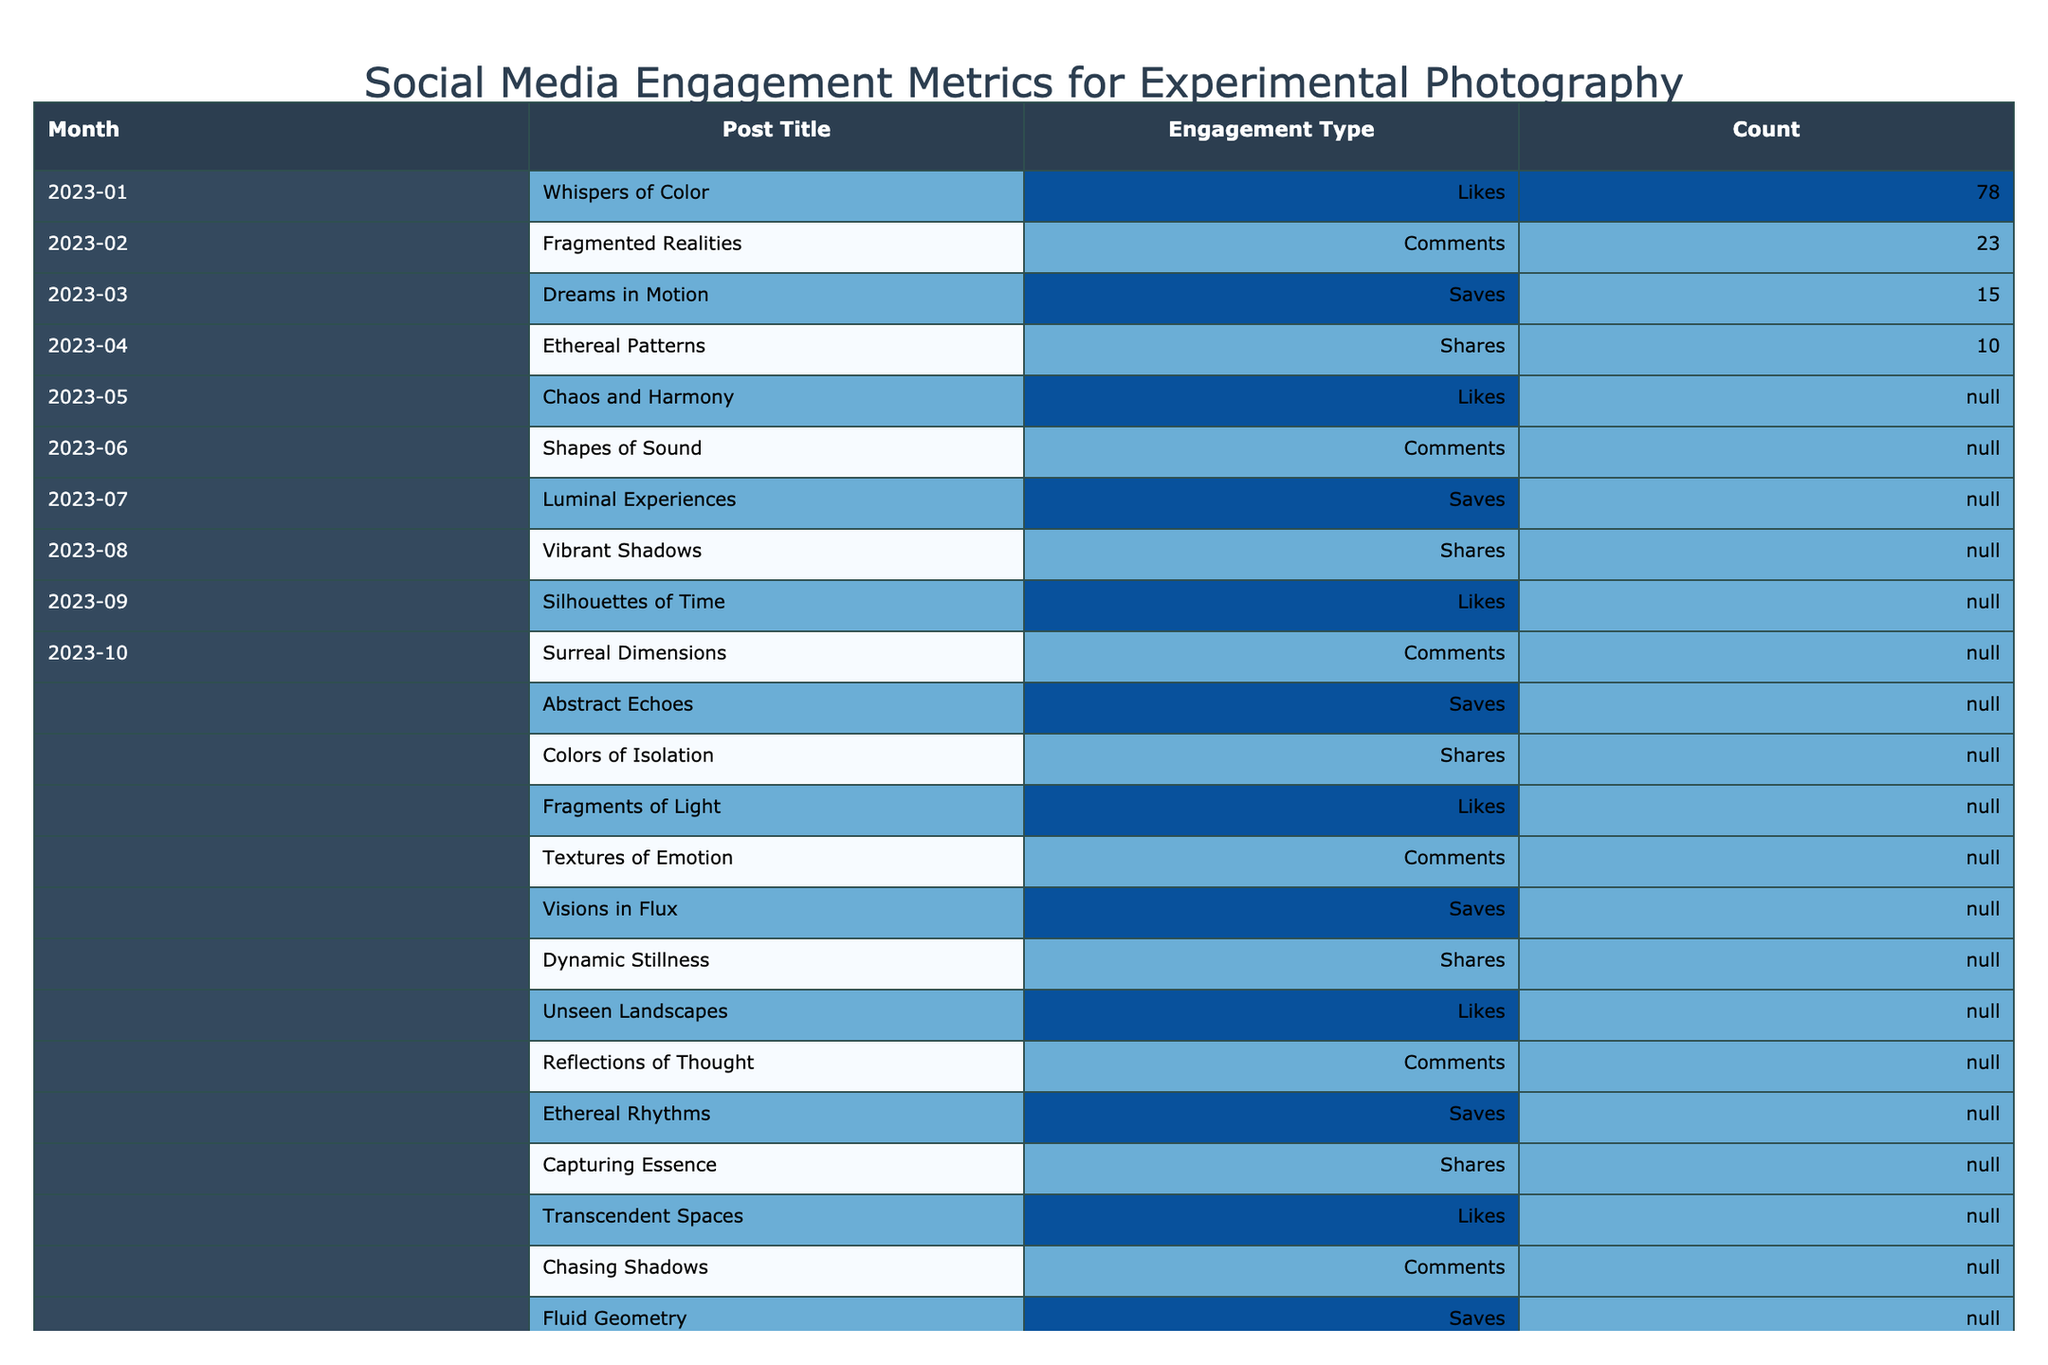What's the total number of likes for January? In January, there is one post titled "Whispers of Color" with 78 likes. Therefore, the total number of likes is 78.
Answer: 78 How many comments did "Transcendent Spaces" receive? "Transcendent Spaces" was posted in June and received 35 comments as indicated in the table.
Answer: 35 Which post in April received the most engagement? In April, "Fragments of Light" received 88 likes, "Textures of Emotion" received 28 comments, "Visions in Flux" received 22 saves, and "Dynamic Stillness" received 16 shares. The highest value is 88 from "Fragments of Light."
Answer: 88 What is the sum of the shares for May and June? In May, "Capturing Essence" received 20 shares, and in June, "Quantum Dreams" received 25 shares. The total is 20 + 25 = 45.
Answer: 45 How many saves did the post titled "Reality Disrupted" receive? "Reality Disrupted" was posted in September and received 18 saves, according to the table.
Answer: 18 Was there ever a post that received more than 30 comments? By checking the comments data, "Chasing Shadows" in June received 35 comments, which is more than 30. Thus, the answer is yes.
Answer: Yes What was the average number of saves over the months? To find the average saves, add all saves from each month: 15 + 20 + 18 + 22 + 25 + 30 + 19 + 16 + 24 + 29 =  208. There are 10 data points, so divide 208 by 10 gives an average of 20.8.
Answer: 20.8 In which month did "Chaos and Harmony" receive 85 likes? "Chaos and Harmony" is listed under February with 85 likes according to the table.
Answer: February Which month had the highest number of total engagements? In June, the engagements were: 110 likes + 35 comments + 30 saves + 25 shares = 200 total engagements. Checking other months, no month exceeded this total. Thus, June has the highest engagements.
Answer: June How does the engagement for "Shapes of Illusion" compare to "Shapes of Sound"? "Shapes of Illusion" received 99 likes in October, while "Shapes of Sound" received 85 likes in February. Thus, "Shapes of Illusion" had 14 more engagements than "Shapes of Sound."
Answer: 14 more 